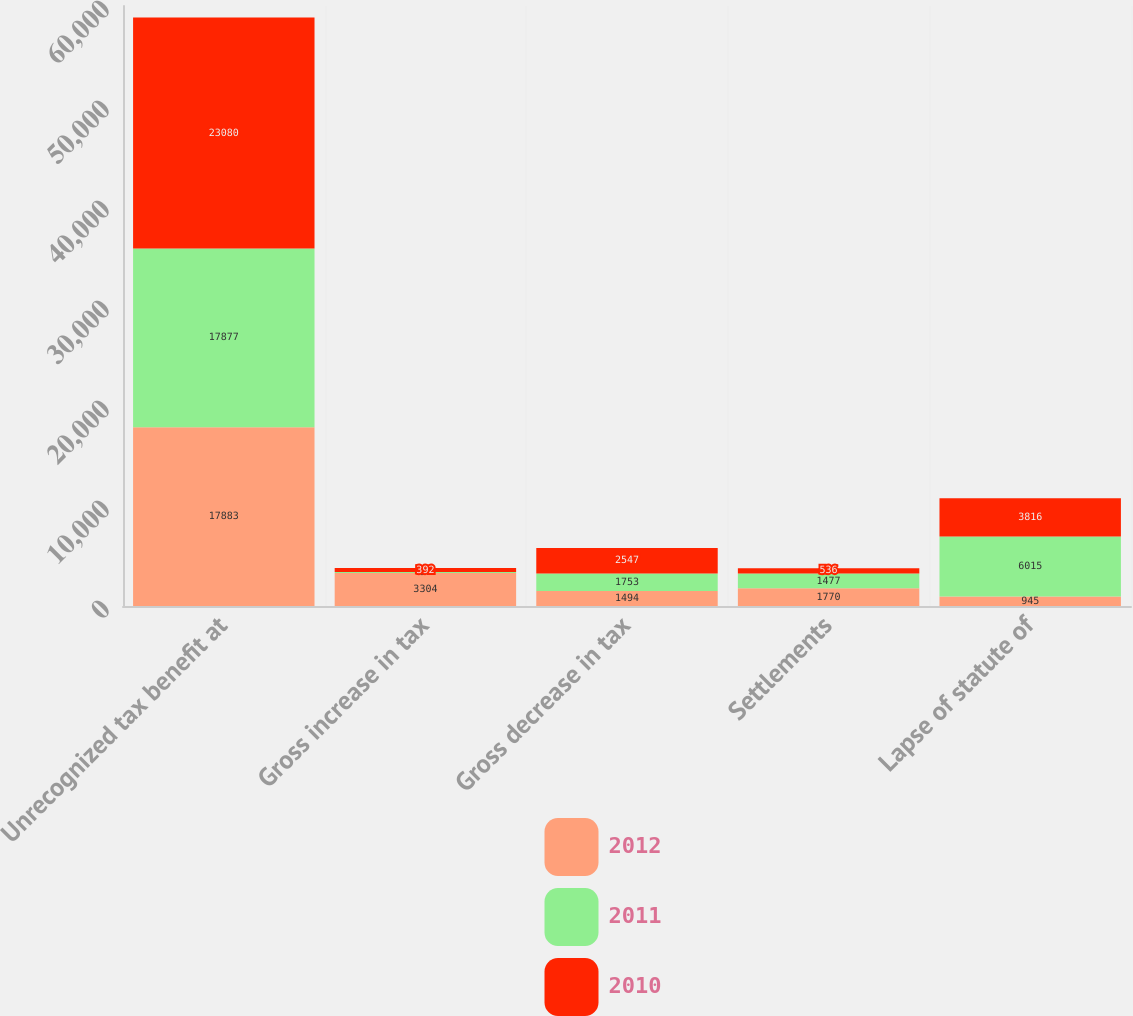<chart> <loc_0><loc_0><loc_500><loc_500><stacked_bar_chart><ecel><fcel>Unrecognized tax benefit at<fcel>Gross increase in tax<fcel>Gross decrease in tax<fcel>Settlements<fcel>Lapse of statute of<nl><fcel>2012<fcel>17883<fcel>3304<fcel>1494<fcel>1770<fcel>945<nl><fcel>2011<fcel>17877<fcel>97<fcel>1753<fcel>1477<fcel>6015<nl><fcel>2010<fcel>23080<fcel>392<fcel>2547<fcel>536<fcel>3816<nl></chart> 